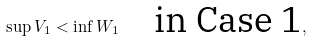<formula> <loc_0><loc_0><loc_500><loc_500>\sup V _ { 1 } < \inf W _ { 1 } \quad \text {in Case 1} ,</formula> 